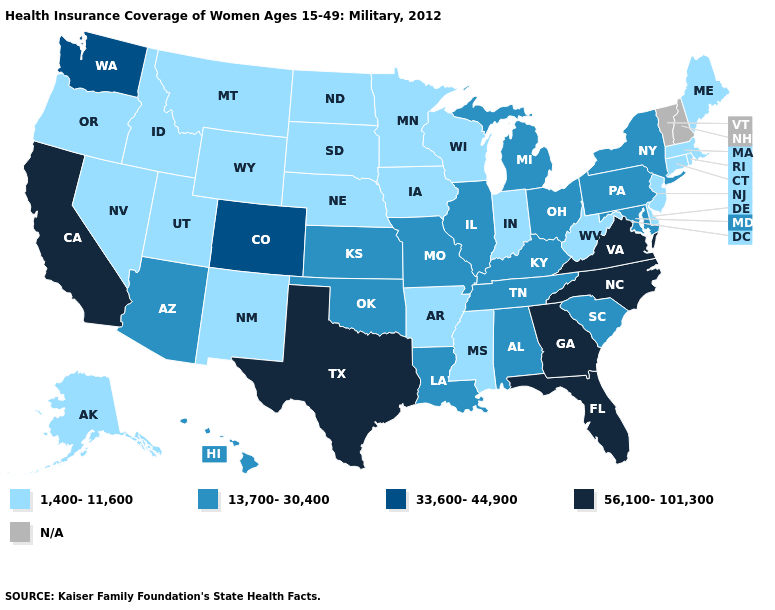What is the value of Massachusetts?
Concise answer only. 1,400-11,600. Among the states that border Delaware , which have the highest value?
Concise answer only. Maryland, Pennsylvania. What is the highest value in the Northeast ?
Keep it brief. 13,700-30,400. What is the value of Kansas?
Write a very short answer. 13,700-30,400. What is the value of South Dakota?
Write a very short answer. 1,400-11,600. What is the value of Arizona?
Answer briefly. 13,700-30,400. Among the states that border Arizona , which have the lowest value?
Answer briefly. Nevada, New Mexico, Utah. Does the first symbol in the legend represent the smallest category?
Short answer required. Yes. What is the value of Delaware?
Quick response, please. 1,400-11,600. Among the states that border Illinois , which have the lowest value?
Concise answer only. Indiana, Iowa, Wisconsin. What is the lowest value in states that border Virginia?
Quick response, please. 1,400-11,600. Does Virginia have the highest value in the USA?
Answer briefly. Yes. Name the states that have a value in the range 33,600-44,900?
Keep it brief. Colorado, Washington. 